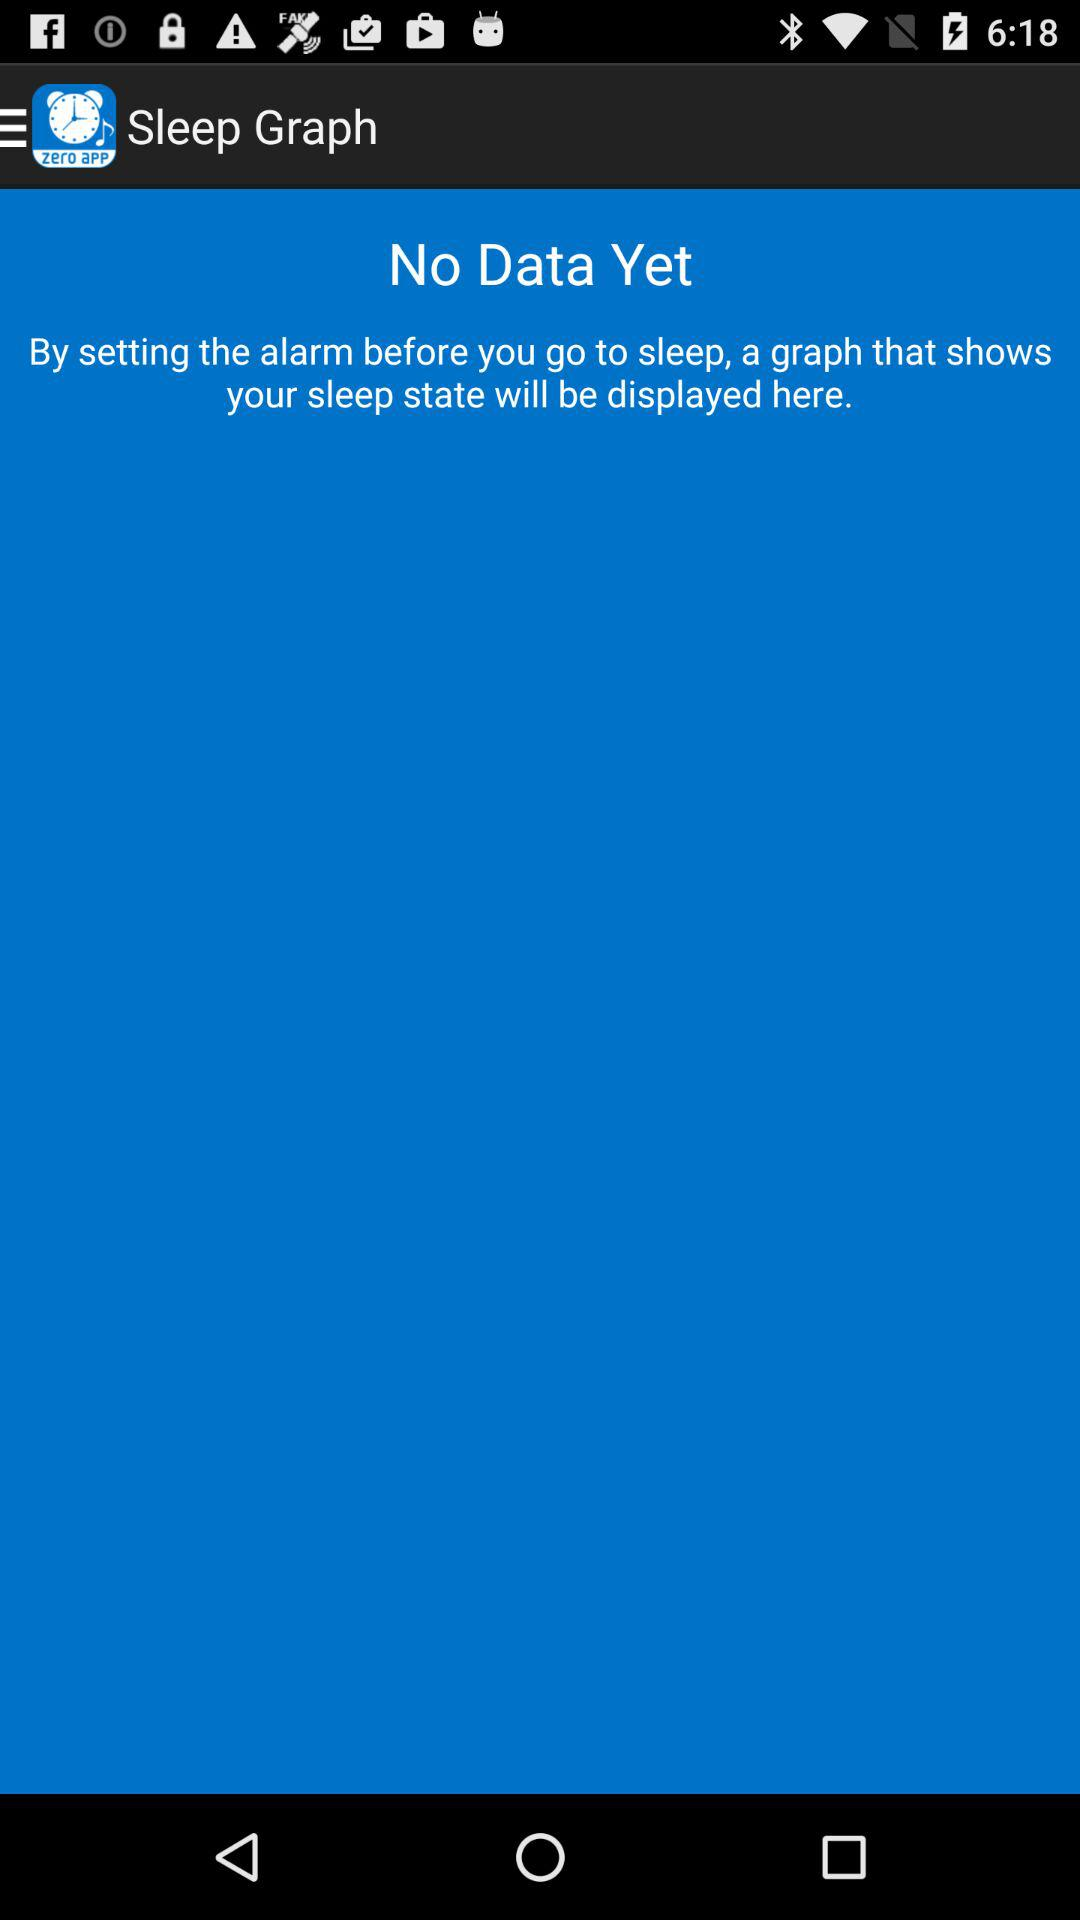Is there any data? There is no data. 